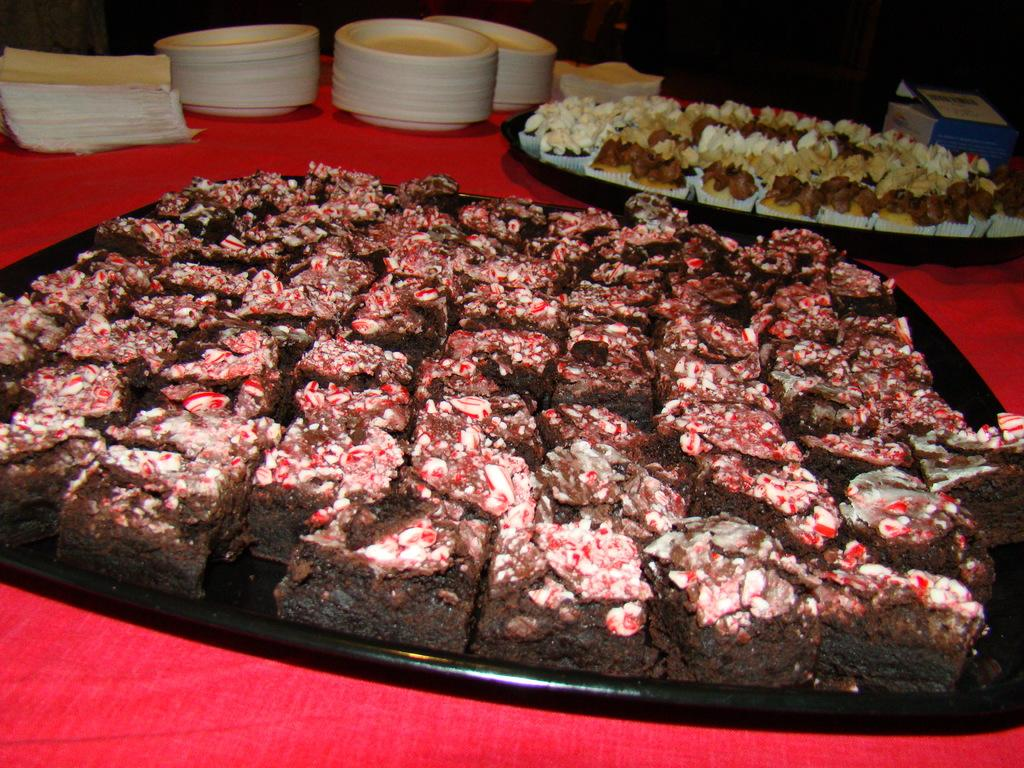What piece of furniture is present in the image? There is a table in the image. What items are placed on the table? There are paper napkins, plates, a carton, and serving plates with desserts on the table. What might be used for wiping or covering the mouth while eating? Paper napkins are present on the table for wiping or covering the mouth while eating. What type of food is visible on the serving plates? Desserts are visible on the serving plates. Can you see your dad walking towards the lake in the image? There is no reference to a dad, walking, or a lake in the image; it only features a table with various items on it. 